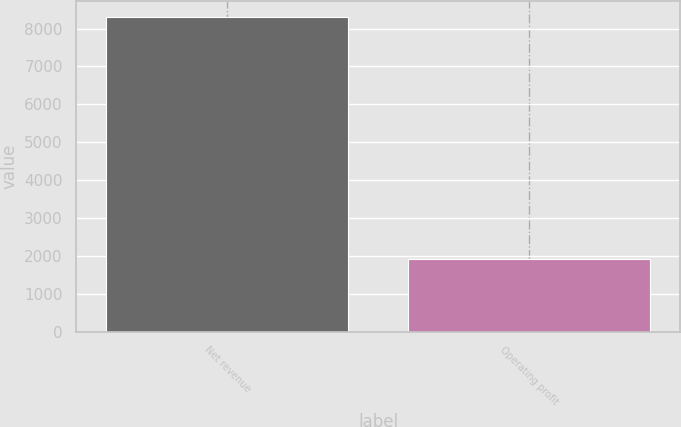Convert chart. <chart><loc_0><loc_0><loc_500><loc_500><bar_chart><fcel>Net revenue<fcel>Operating profit<nl><fcel>8313<fcel>1911<nl></chart> 